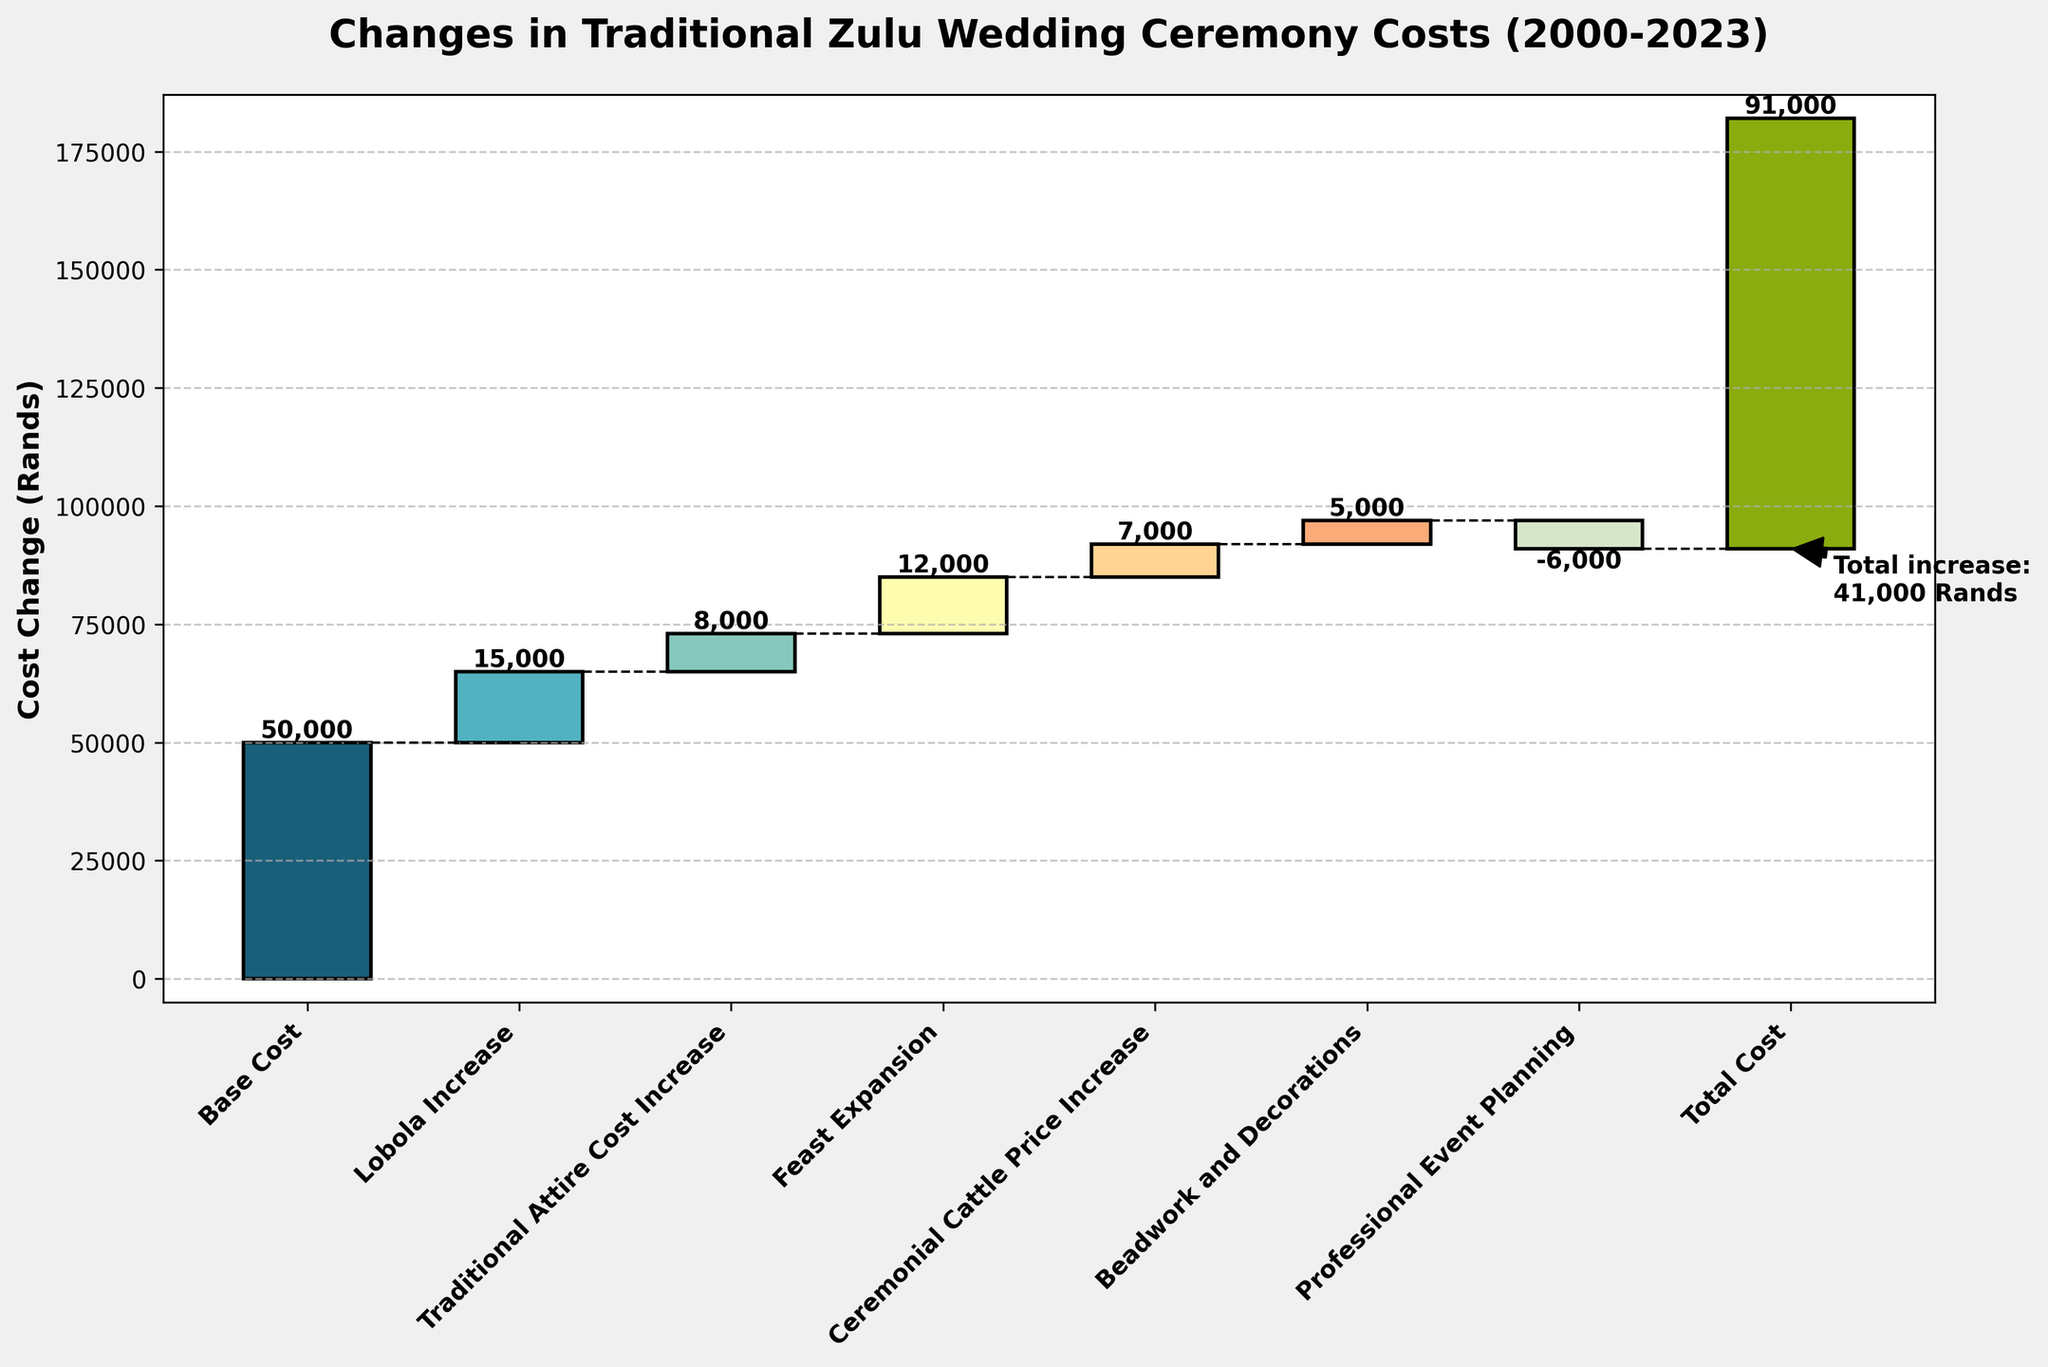What is the title of the plot? The title of the plot is written at the top center of the figure. It reads "Changes in Traditional Zulu Wedding Ceremony Costs (2000-2023)."
Answer: Changes in Traditional Zulu Wedding Ceremony Costs (2000-2023) What is the value of the initial base cost in the year 2000? The starting value or base cost is represented by the first bar on the x-axis and the label "Base Cost." According to this bar, the value is 50000.
Answer: 50000 Between which years did the cost of the Lobola increase? The "Lobola Increase" is labeled on the x-axis and its value change segment shows a positive increase. This corresponds to the year 2005.
Answer: 2000-2005 How much did the cost of professional event planning decrease in 2022? The "Professional Event Planning" segment is labeled on the x-axis and shows a decrease represented by a downward bar. The value change in this bar is -6000.
Answer: 6000 What is the total cumulative cost by 2023? The final segment labeled "Total Cost" after summing up all preceding segments gives the overall cost, which is shown to be 91000.
Answer: 91000 What is the net increase in cost from 2000 to 2023? Calculate the net increase by subtracting the base cost in 2000 from the total cost in 2023, i.e., 91000 - 50000.
Answer: 41000 Which specific cost increase has the highest amount, and what is it? Among the segments labeled on the x-axis, look for the largest increase besides the base. The "Feast Expansion" has the highest cost increase, which is represented by the value 12000.
Answer: Feast Expansion, 12000 How many distinct types of cost changes are shown up to the year 2023? Count the distinct categories labeled along the x-axis from "Base Cost" to "Total Cost," excluding "Total Cost." There are 7 distinct types of cost changes.
Answer: 7 What impact does beadwork and decorations have on the total cost in 2020? The "Beadwork and Decorations" segment on the x-axis shows an increase, indicated by a positive value change. The value is 5000.
Answer: Increase by 5000 Is the cost change from the "Traditional Attire Cost Increase" greater or less than the "Ceremonial Cattle Price Increase"? Compare the values of these two categories. The "Traditional Attire Cost Increase" (8000) is greater than the "Ceremonial Cattle Price Increase" (7000).
Answer: Greater 